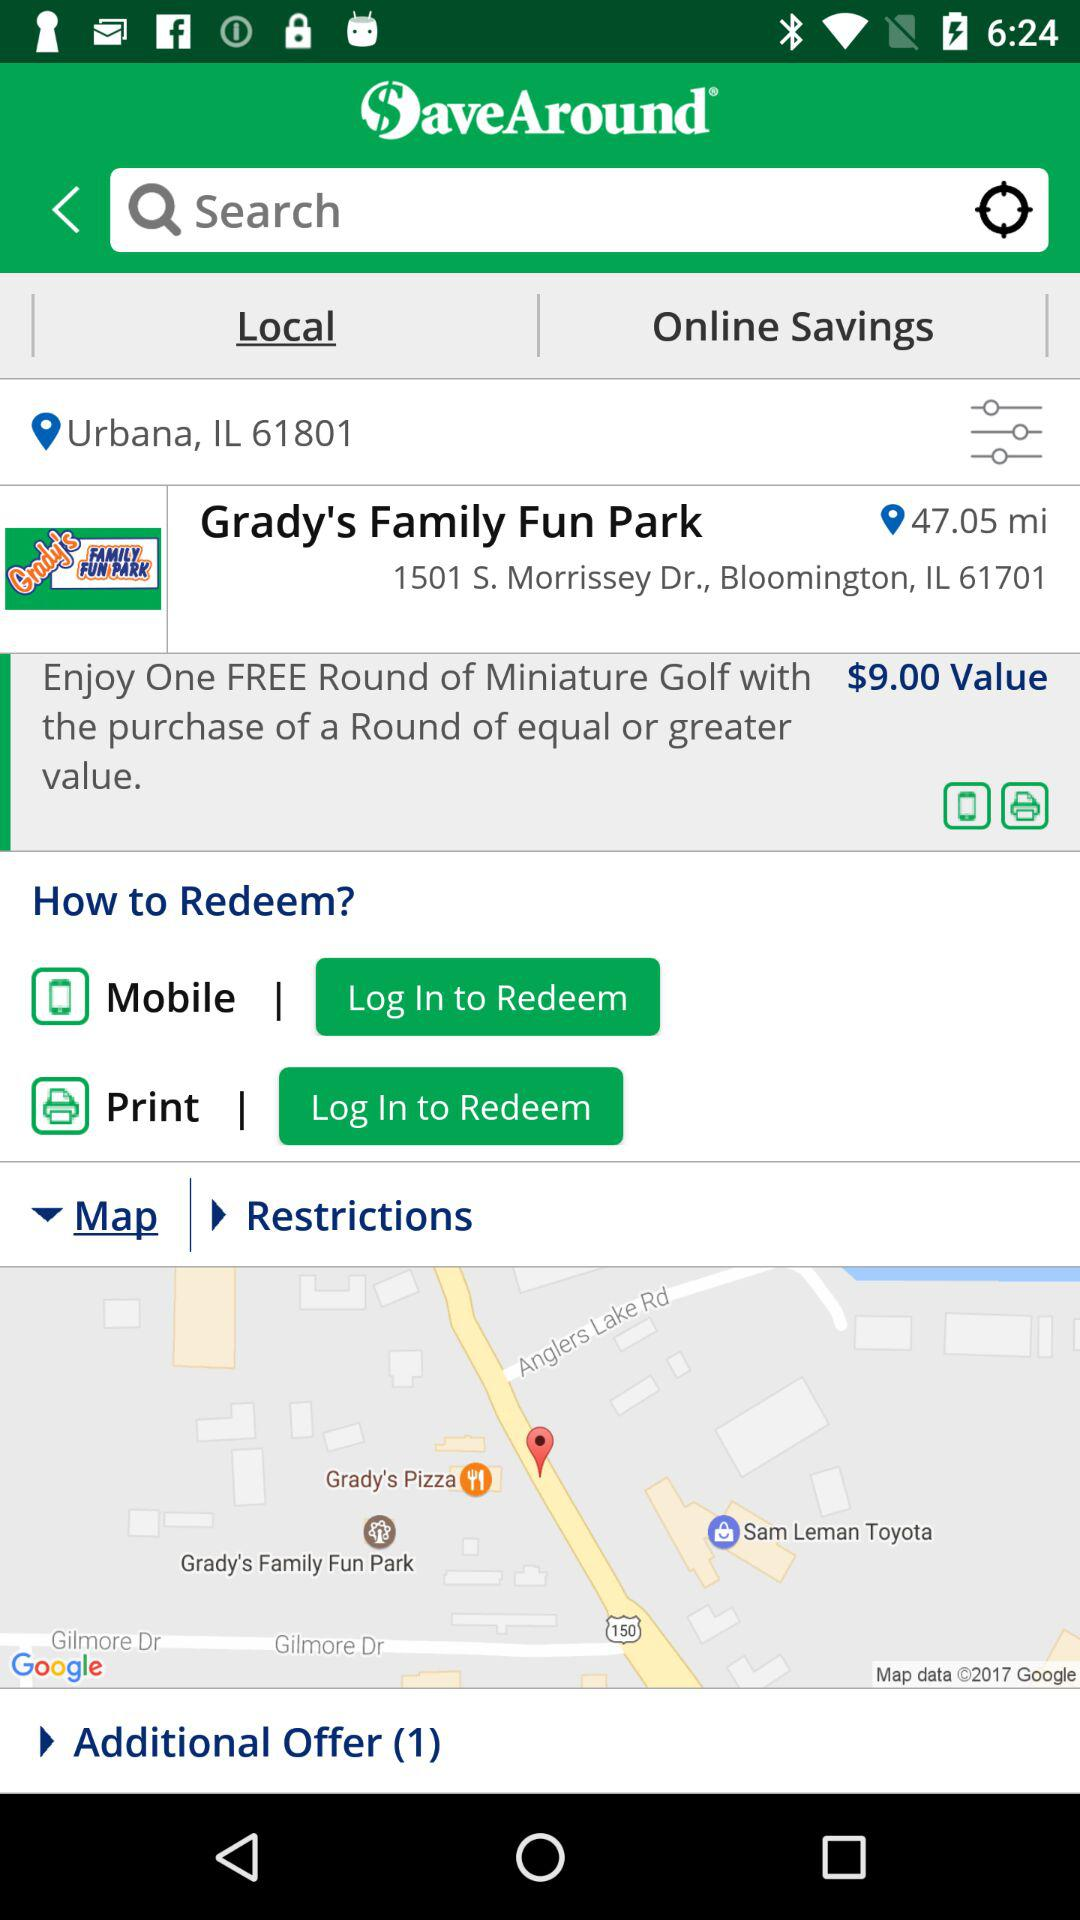How many ways can the user redeem the offer?
Answer the question using a single word or phrase. 2 